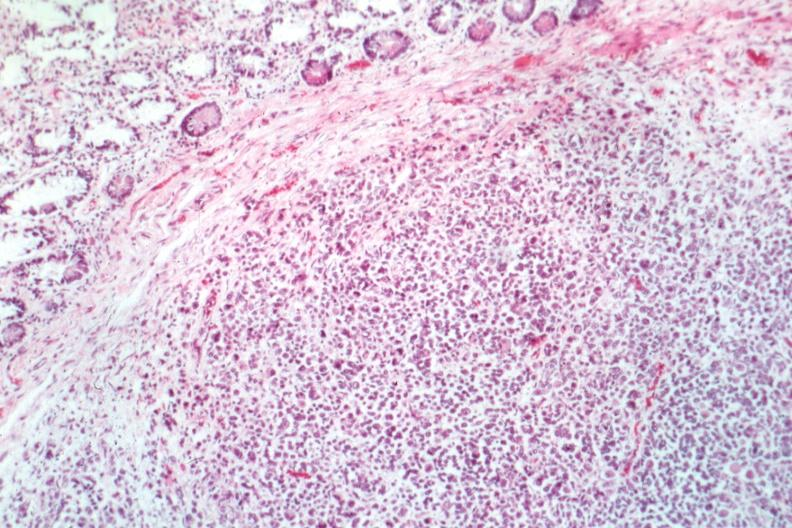s lesion in dome of uterus present?
Answer the question using a single word or phrase. No 